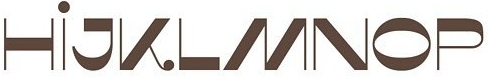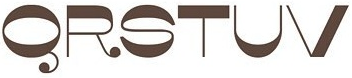What text appears in these images from left to right, separated by a semicolon? HİJKLMNOP; QRSTUV 